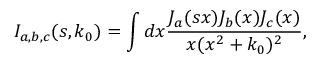Convert formula to latex. <formula><loc_0><loc_0><loc_500><loc_500>I _ { a , b , c } ( s , k _ { 0 } ) = \int d x \frac { J _ { a } ( s x ) J _ { b } ( x ) J _ { c } ( x ) } { x ( x ^ { 2 } + k _ { 0 } ) ^ { 2 } } ,</formula> 